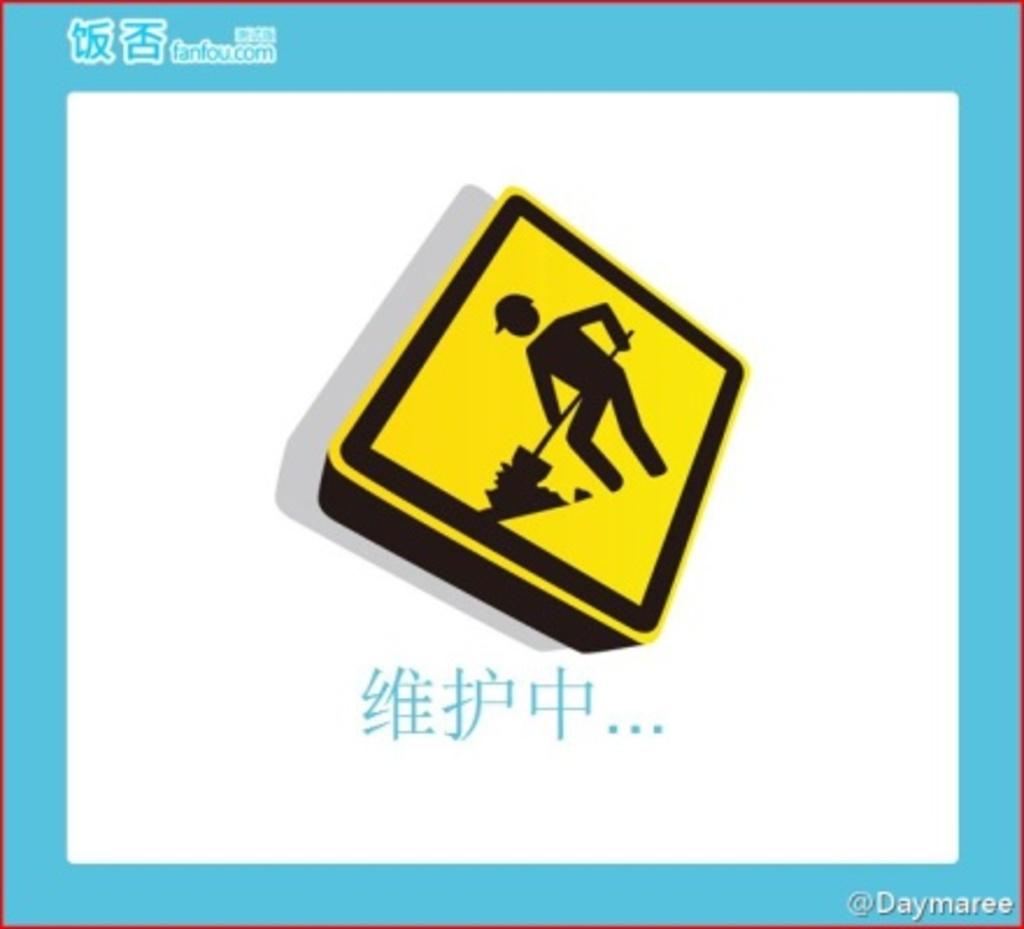What is the website address at the top?
Offer a very short reply. Fanfou.com. 